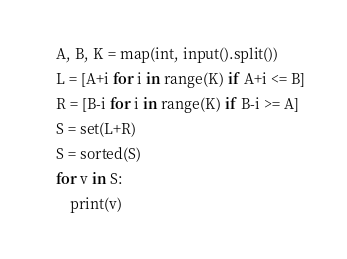<code> <loc_0><loc_0><loc_500><loc_500><_Python_>A, B, K = map(int, input().split())
L = [A+i for i in range(K) if A+i <= B]
R = [B-i for i in range(K) if B-i >= A]
S = set(L+R)
S = sorted(S)
for v in S:
    print(v)</code> 